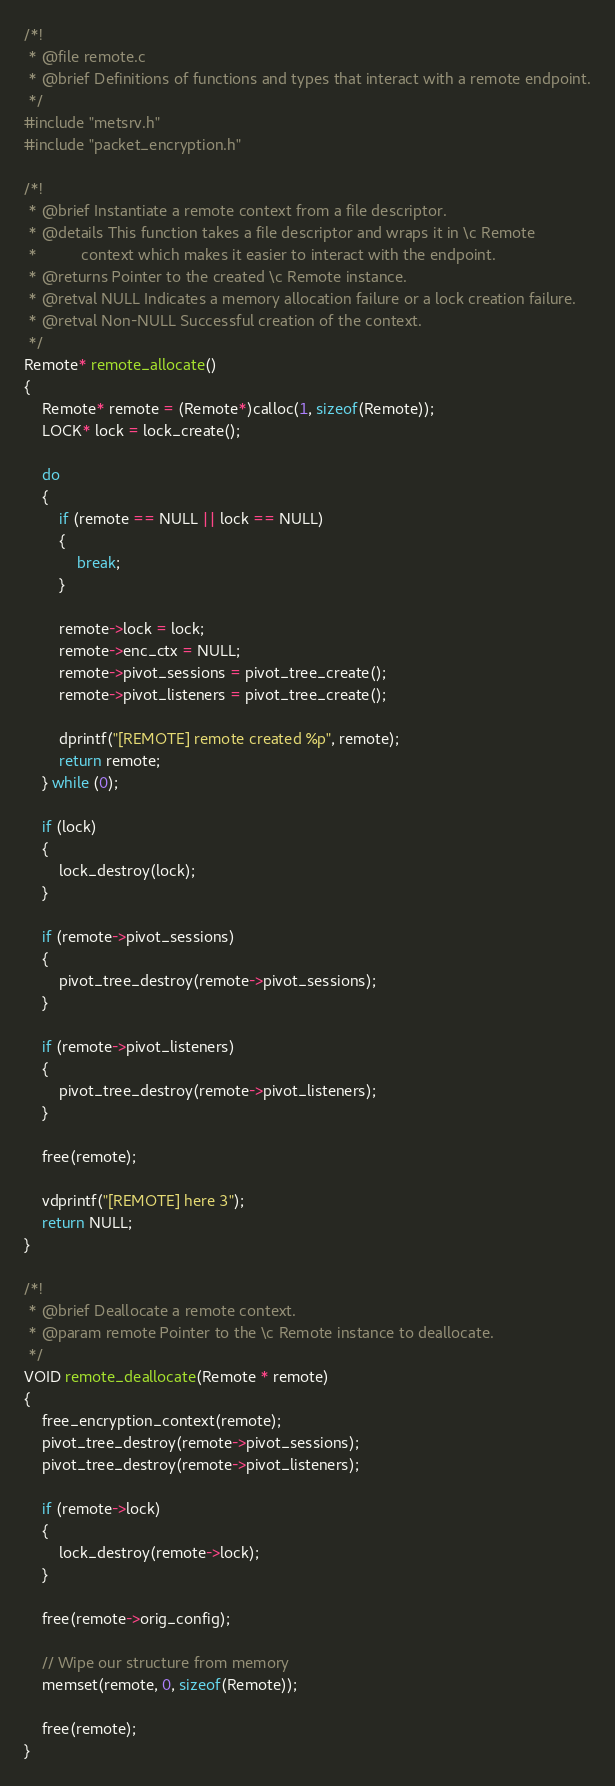<code> <loc_0><loc_0><loc_500><loc_500><_C_>/*!
 * @file remote.c
 * @brief Definitions of functions and types that interact with a remote endpoint.
 */
#include "metsrv.h"
#include "packet_encryption.h"

/*!
 * @brief Instantiate a remote context from a file descriptor.
 * @details This function takes a file descriptor and wraps it in \c Remote
 *          context which makes it easier to interact with the endpoint.
 * @returns Pointer to the created \c Remote instance.
 * @retval NULL Indicates a memory allocation failure or a lock creation failure.
 * @retval Non-NULL Successful creation of the context.
 */
Remote* remote_allocate()
{
	Remote* remote = (Remote*)calloc(1, sizeof(Remote));
	LOCK* lock = lock_create();

	do
	{
		if (remote == NULL || lock == NULL)
		{
			break;
		}

		remote->lock = lock;
		remote->enc_ctx = NULL;
		remote->pivot_sessions = pivot_tree_create();
		remote->pivot_listeners = pivot_tree_create();

		dprintf("[REMOTE] remote created %p", remote);
		return remote;
	} while (0);

	if (lock)
	{
		lock_destroy(lock);
	}

	if (remote->pivot_sessions)
	{
		pivot_tree_destroy(remote->pivot_sessions);
	}

	if (remote->pivot_listeners)
	{
		pivot_tree_destroy(remote->pivot_listeners);
	}

	free(remote);

	vdprintf("[REMOTE] here 3");
	return NULL;
}

/*!
 * @brief Deallocate a remote context.
 * @param remote Pointer to the \c Remote instance to deallocate.
 */
VOID remote_deallocate(Remote * remote)
{
	free_encryption_context(remote);
	pivot_tree_destroy(remote->pivot_sessions);
	pivot_tree_destroy(remote->pivot_listeners);

	if (remote->lock)
	{
		lock_destroy(remote->lock);
	}

	free(remote->orig_config);

	// Wipe our structure from memory
	memset(remote, 0, sizeof(Remote));

	free(remote);
}
</code> 